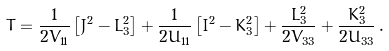<formula> <loc_0><loc_0><loc_500><loc_500>T = \frac { 1 } { 2 V _ { 1 1 } } \left [ J ^ { 2 } - L _ { 3 } ^ { 2 } \right ] + \frac { 1 } { 2 U _ { 1 1 } } \left [ I ^ { 2 } - K _ { 3 } ^ { 2 } \right ] + \frac { L _ { 3 } ^ { 2 } } { 2 V _ { 3 3 } } + \frac { K _ { 3 } ^ { 2 } } { 2 U _ { 3 3 } } \, .</formula> 